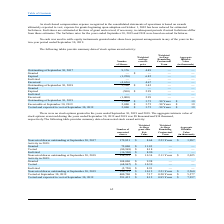According to Csp's financial document, What is the number of outstanding shares as at September 30, 2017? According to the financial document, 9,376 (in thousands). The relevant text states: "Outstanding at September 30, 2017 9,376 4.49 — —..." Also, When was stock based compensation adopted by the company? According to the financial document, October 1, 2005 (in thousands). The relevant text states: "st, expense for grants beginning upon adoption on October 1, 2005 has been reduced for estimated forfeitures. Forfeitures are estimated at the time of grant and revi..." Also, What is the number of shares vested and expected to vest at September 30, 2019 According to the financial document, 2,000 (in thousands). The relevant text states: "Outstanding at September 30, 2019 2,000 $ 3.75 .98 Years $ 19..." Also, can you calculate: What is the amount lost from the expired shares in 2017? Based on the calculation: 1,250 * 6.82 , the result is 8525 (in thousands). This is based on the information: "Expired (1,250) 6.82 — — Expired (1,250) 6.82 — —..." The key data points involved are: 1,250, 6.82. Also, can you calculate: What is the total number of expired shares in 2017 and 2018? Based on the calculation: 1,250 + 500 , the result is 1750. This is based on the information: "Expired (1,250) 6.82 — — Expired (1,250) 6.82 — —..." The key data points involved are: 1,250, 500. Also, can you calculate: What is the percentage of outstanding shares as at September 30, 2019 expired between September 30, 2018 and 2019? Based on the calculation: 500/2,000 , the result is 25 (percentage). This is based on the information: "Outstanding at September 30, 2019 2,000 $ 3.75 .98 Years $ 19 Outstanding at September 30, 2018 3,500 $ 3.42 — —..." The key data points involved are: 2,000, 500. 